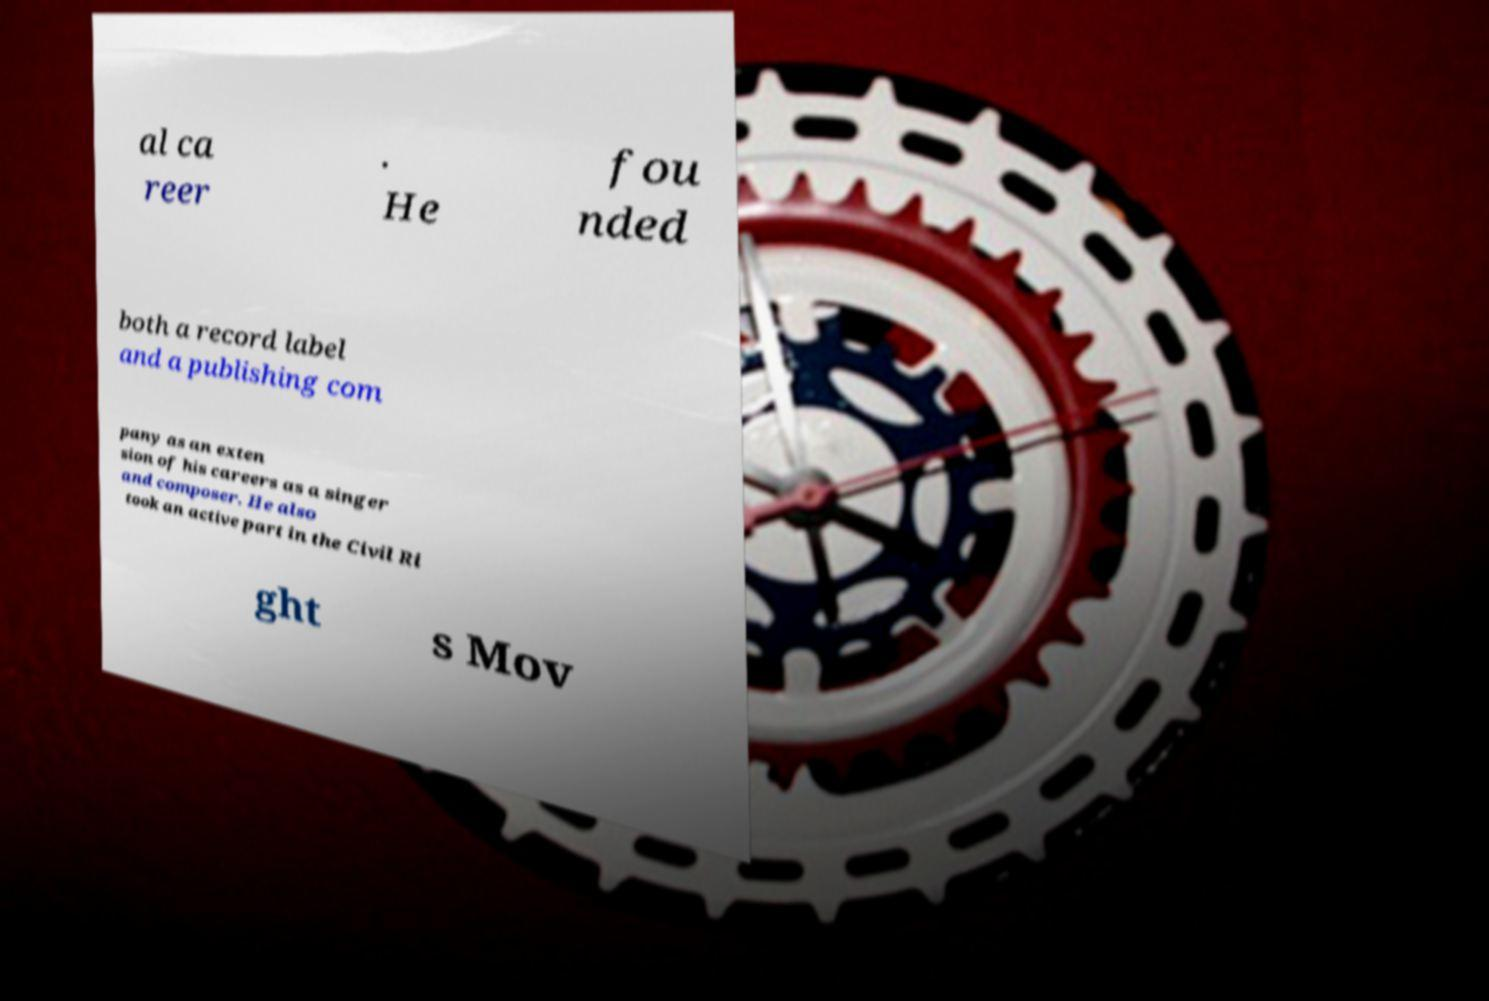Can you accurately transcribe the text from the provided image for me? al ca reer . He fou nded both a record label and a publishing com pany as an exten sion of his careers as a singer and composer. He also took an active part in the Civil Ri ght s Mov 